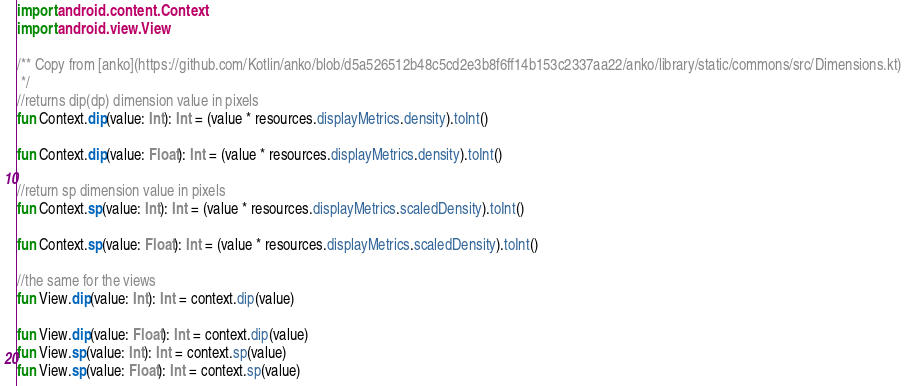<code> <loc_0><loc_0><loc_500><loc_500><_Kotlin_>import android.content.Context
import android.view.View

/** Copy from [anko](https://github.com/Kotlin/anko/blob/d5a526512b48c5cd2e3b8f6ff14b153c2337aa22/anko/library/static/commons/src/Dimensions.kt)
 */
//returns dip(dp) dimension value in pixels
fun Context.dip(value: Int): Int = (value * resources.displayMetrics.density).toInt()

fun Context.dip(value: Float): Int = (value * resources.displayMetrics.density).toInt()

//return sp dimension value in pixels
fun Context.sp(value: Int): Int = (value * resources.displayMetrics.scaledDensity).toInt()

fun Context.sp(value: Float): Int = (value * resources.displayMetrics.scaledDensity).toInt()

//the same for the views
fun View.dip(value: Int): Int = context.dip(value)

fun View.dip(value: Float): Int = context.dip(value)
fun View.sp(value: Int): Int = context.sp(value)
fun View.sp(value: Float): Int = context.sp(value)</code> 